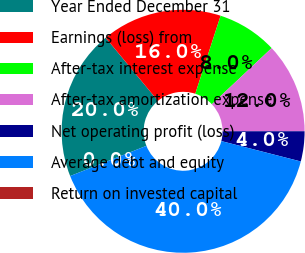<chart> <loc_0><loc_0><loc_500><loc_500><pie_chart><fcel>Year Ended December 31<fcel>Earnings (loss) from<fcel>After-tax interest expense<fcel>After-tax amortization expense<fcel>Net operating profit (loss)<fcel>Average debt and equity<fcel>Return on invested capital<nl><fcel>20.0%<fcel>16.0%<fcel>8.0%<fcel>12.0%<fcel>4.0%<fcel>40.0%<fcel>0.0%<nl></chart> 